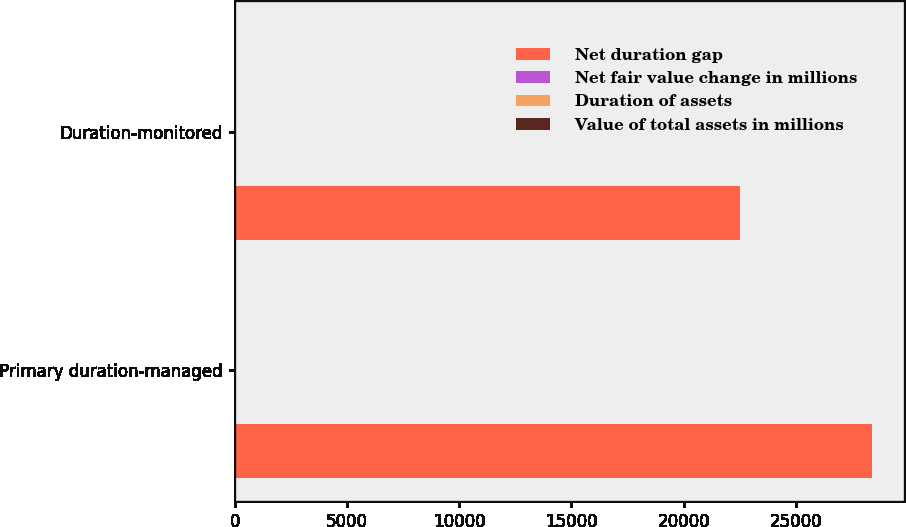<chart> <loc_0><loc_0><loc_500><loc_500><stacked_bar_chart><ecel><fcel>Primary duration-managed<fcel>Duration-monitored<nl><fcel>Net duration gap<fcel>28377.1<fcel>22497.1<nl><fcel>Net fair value change in millions<fcel>3.4<fcel>4.13<nl><fcel>Duration of assets<fcel>0.12<fcel>0.16<nl><fcel>Value of total assets in millions<fcel>34.1<fcel>37<nl></chart> 